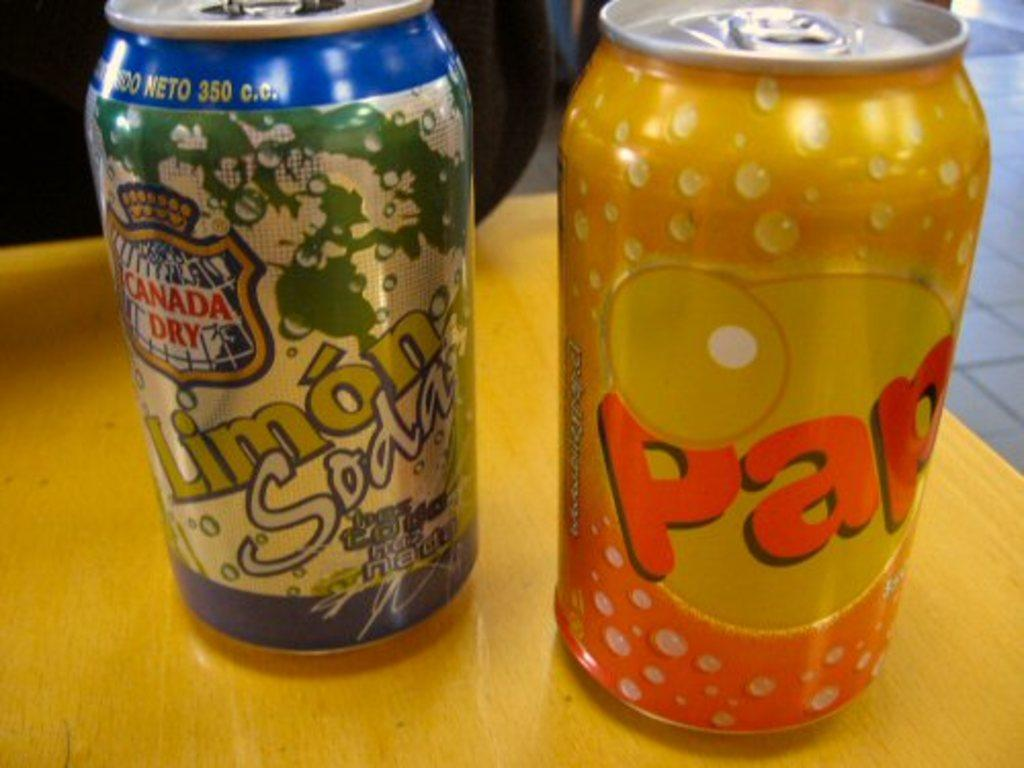<image>
Describe the image concisely. A can of Canada Dry Limon soda on the left and an orange can of pap soda on the right on a table. 